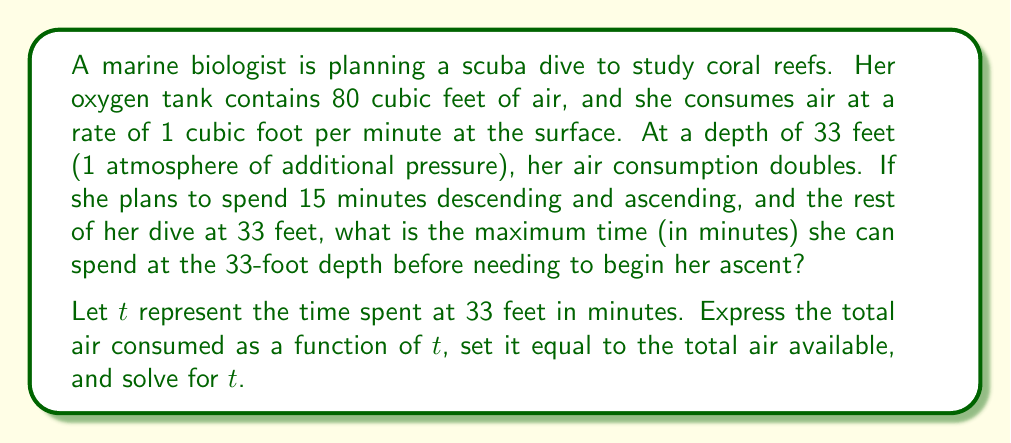Teach me how to tackle this problem. To solve this problem, we need to consider the air consumption at different stages of the dive:

1) Descent and ascent: 15 minutes at surface consumption rate
   Air consumed = $15 \cdot 1 = 15$ cubic feet

2) Time at 33 feet: $t$ minutes at double the surface consumption rate
   Air consumed = $t \cdot 2 = 2t$ cubic feet

Total air consumed = Air for descent/ascent + Air at depth
$$15 + 2t = 80$$

Now we can solve for $t$:

$$\begin{align}
15 + 2t &= 80 \\
2t &= 65 \\
t &= \frac{65}{2} = 32.5
\end{align}$$

Therefore, the maximum time the marine biologist can spend at the 33-foot depth is 32.5 minutes.

To verify:
- Air used for descent/ascent: 15 cubic feet
- Air used at depth: $2 \cdot 32.5 = 65$ cubic feet
- Total air used: $15 + 65 = 80$ cubic feet, which matches the tank capacity.
Answer: The marine biologist can spend a maximum of 32.5 minutes at the 33-foot depth. 